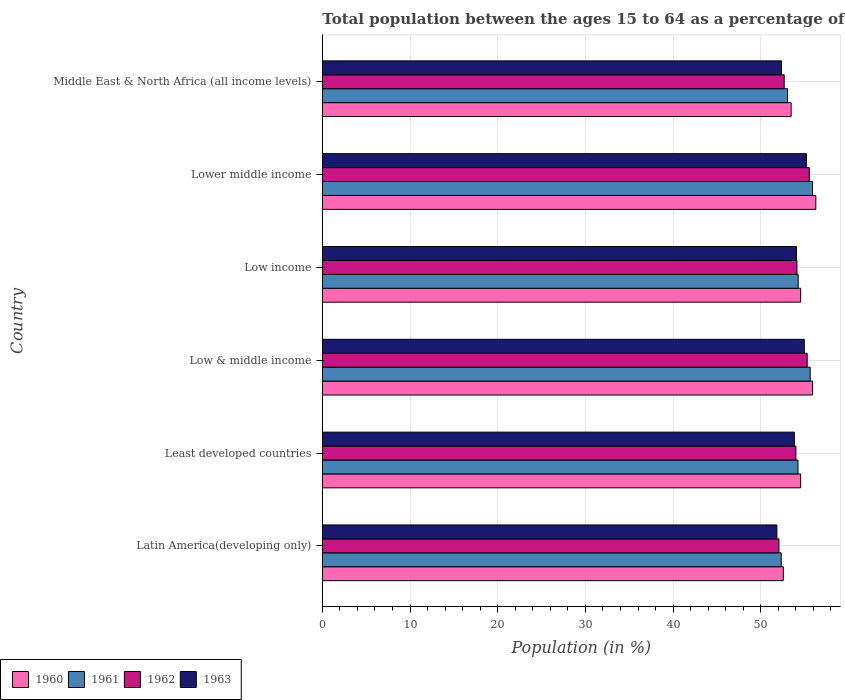How many bars are there on the 2nd tick from the top?
Keep it short and to the point. 4. What is the label of the 5th group of bars from the top?
Provide a short and direct response. Least developed countries. What is the percentage of the population ages 15 to 64 in 1963 in Least developed countries?
Offer a terse response. 53.82. Across all countries, what is the maximum percentage of the population ages 15 to 64 in 1961?
Your answer should be very brief. 55.89. Across all countries, what is the minimum percentage of the population ages 15 to 64 in 1960?
Offer a terse response. 52.56. In which country was the percentage of the population ages 15 to 64 in 1961 maximum?
Keep it short and to the point. Lower middle income. In which country was the percentage of the population ages 15 to 64 in 1961 minimum?
Your answer should be very brief. Latin America(developing only). What is the total percentage of the population ages 15 to 64 in 1963 in the graph?
Provide a succinct answer. 322.22. What is the difference between the percentage of the population ages 15 to 64 in 1962 in Latin America(developing only) and that in Least developed countries?
Ensure brevity in your answer.  -1.94. What is the difference between the percentage of the population ages 15 to 64 in 1962 in Latin America(developing only) and the percentage of the population ages 15 to 64 in 1961 in Lower middle income?
Your response must be concise. -3.83. What is the average percentage of the population ages 15 to 64 in 1960 per country?
Your answer should be very brief. 54.55. What is the difference between the percentage of the population ages 15 to 64 in 1962 and percentage of the population ages 15 to 64 in 1960 in Lower middle income?
Provide a short and direct response. -0.74. What is the ratio of the percentage of the population ages 15 to 64 in 1961 in Latin America(developing only) to that in Middle East & North Africa (all income levels)?
Give a very brief answer. 0.99. What is the difference between the highest and the second highest percentage of the population ages 15 to 64 in 1960?
Your answer should be compact. 0.37. What is the difference between the highest and the lowest percentage of the population ages 15 to 64 in 1961?
Offer a terse response. 3.57. In how many countries, is the percentage of the population ages 15 to 64 in 1962 greater than the average percentage of the population ages 15 to 64 in 1962 taken over all countries?
Provide a short and direct response. 4. Is the sum of the percentage of the population ages 15 to 64 in 1961 in Latin America(developing only) and Least developed countries greater than the maximum percentage of the population ages 15 to 64 in 1960 across all countries?
Provide a short and direct response. Yes. Are all the bars in the graph horizontal?
Provide a succinct answer. Yes. How many countries are there in the graph?
Offer a very short reply. 6. How many legend labels are there?
Provide a succinct answer. 4. How are the legend labels stacked?
Your answer should be very brief. Horizontal. What is the title of the graph?
Your response must be concise. Total population between the ages 15 to 64 as a percentage of the total population. Does "1983" appear as one of the legend labels in the graph?
Ensure brevity in your answer.  No. What is the Population (in %) of 1960 in Latin America(developing only)?
Offer a very short reply. 52.56. What is the Population (in %) of 1961 in Latin America(developing only)?
Ensure brevity in your answer.  52.32. What is the Population (in %) of 1962 in Latin America(developing only)?
Offer a terse response. 52.06. What is the Population (in %) of 1963 in Latin America(developing only)?
Give a very brief answer. 51.83. What is the Population (in %) in 1960 in Least developed countries?
Your answer should be compact. 54.54. What is the Population (in %) in 1961 in Least developed countries?
Offer a very short reply. 54.24. What is the Population (in %) of 1962 in Least developed countries?
Keep it short and to the point. 54. What is the Population (in %) of 1963 in Least developed countries?
Give a very brief answer. 53.82. What is the Population (in %) of 1960 in Low & middle income?
Offer a terse response. 55.9. What is the Population (in %) in 1961 in Low & middle income?
Your answer should be compact. 55.63. What is the Population (in %) in 1962 in Low & middle income?
Keep it short and to the point. 55.29. What is the Population (in %) of 1963 in Low & middle income?
Keep it short and to the point. 54.96. What is the Population (in %) in 1960 in Low income?
Make the answer very short. 54.54. What is the Population (in %) of 1961 in Low income?
Make the answer very short. 54.26. What is the Population (in %) in 1962 in Low income?
Give a very brief answer. 54.11. What is the Population (in %) in 1963 in Low income?
Make the answer very short. 54.06. What is the Population (in %) of 1960 in Lower middle income?
Make the answer very short. 56.27. What is the Population (in %) in 1961 in Lower middle income?
Ensure brevity in your answer.  55.89. What is the Population (in %) of 1962 in Lower middle income?
Ensure brevity in your answer.  55.53. What is the Population (in %) in 1963 in Lower middle income?
Give a very brief answer. 55.2. What is the Population (in %) in 1960 in Middle East & North Africa (all income levels)?
Provide a succinct answer. 53.46. What is the Population (in %) in 1961 in Middle East & North Africa (all income levels)?
Your response must be concise. 53.04. What is the Population (in %) in 1962 in Middle East & North Africa (all income levels)?
Make the answer very short. 52.67. What is the Population (in %) in 1963 in Middle East & North Africa (all income levels)?
Provide a short and direct response. 52.35. Across all countries, what is the maximum Population (in %) in 1960?
Your response must be concise. 56.27. Across all countries, what is the maximum Population (in %) of 1961?
Provide a succinct answer. 55.89. Across all countries, what is the maximum Population (in %) of 1962?
Your response must be concise. 55.53. Across all countries, what is the maximum Population (in %) in 1963?
Give a very brief answer. 55.2. Across all countries, what is the minimum Population (in %) of 1960?
Your answer should be compact. 52.56. Across all countries, what is the minimum Population (in %) of 1961?
Offer a very short reply. 52.32. Across all countries, what is the minimum Population (in %) of 1962?
Your answer should be very brief. 52.06. Across all countries, what is the minimum Population (in %) in 1963?
Ensure brevity in your answer.  51.83. What is the total Population (in %) in 1960 in the graph?
Offer a terse response. 327.28. What is the total Population (in %) of 1961 in the graph?
Keep it short and to the point. 325.38. What is the total Population (in %) of 1962 in the graph?
Give a very brief answer. 323.65. What is the total Population (in %) in 1963 in the graph?
Make the answer very short. 322.22. What is the difference between the Population (in %) in 1960 in Latin America(developing only) and that in Least developed countries?
Ensure brevity in your answer.  -1.98. What is the difference between the Population (in %) of 1961 in Latin America(developing only) and that in Least developed countries?
Provide a succinct answer. -1.91. What is the difference between the Population (in %) of 1962 in Latin America(developing only) and that in Least developed countries?
Ensure brevity in your answer.  -1.94. What is the difference between the Population (in %) of 1963 in Latin America(developing only) and that in Least developed countries?
Keep it short and to the point. -1.99. What is the difference between the Population (in %) in 1960 in Latin America(developing only) and that in Low & middle income?
Your response must be concise. -3.34. What is the difference between the Population (in %) in 1961 in Latin America(developing only) and that in Low & middle income?
Ensure brevity in your answer.  -3.31. What is the difference between the Population (in %) in 1962 in Latin America(developing only) and that in Low & middle income?
Your response must be concise. -3.22. What is the difference between the Population (in %) in 1963 in Latin America(developing only) and that in Low & middle income?
Your answer should be very brief. -3.13. What is the difference between the Population (in %) of 1960 in Latin America(developing only) and that in Low income?
Ensure brevity in your answer.  -1.98. What is the difference between the Population (in %) in 1961 in Latin America(developing only) and that in Low income?
Give a very brief answer. -1.94. What is the difference between the Population (in %) in 1962 in Latin America(developing only) and that in Low income?
Make the answer very short. -2.05. What is the difference between the Population (in %) in 1963 in Latin America(developing only) and that in Low income?
Your answer should be very brief. -2.22. What is the difference between the Population (in %) in 1960 in Latin America(developing only) and that in Lower middle income?
Make the answer very short. -3.71. What is the difference between the Population (in %) in 1961 in Latin America(developing only) and that in Lower middle income?
Provide a succinct answer. -3.57. What is the difference between the Population (in %) of 1962 in Latin America(developing only) and that in Lower middle income?
Offer a very short reply. -3.46. What is the difference between the Population (in %) of 1963 in Latin America(developing only) and that in Lower middle income?
Keep it short and to the point. -3.37. What is the difference between the Population (in %) of 1960 in Latin America(developing only) and that in Middle East & North Africa (all income levels)?
Provide a succinct answer. -0.89. What is the difference between the Population (in %) of 1961 in Latin America(developing only) and that in Middle East & North Africa (all income levels)?
Provide a short and direct response. -0.72. What is the difference between the Population (in %) in 1962 in Latin America(developing only) and that in Middle East & North Africa (all income levels)?
Your answer should be compact. -0.6. What is the difference between the Population (in %) in 1963 in Latin America(developing only) and that in Middle East & North Africa (all income levels)?
Provide a succinct answer. -0.52. What is the difference between the Population (in %) of 1960 in Least developed countries and that in Low & middle income?
Give a very brief answer. -1.36. What is the difference between the Population (in %) in 1961 in Least developed countries and that in Low & middle income?
Your answer should be very brief. -1.39. What is the difference between the Population (in %) in 1962 in Least developed countries and that in Low & middle income?
Keep it short and to the point. -1.29. What is the difference between the Population (in %) in 1963 in Least developed countries and that in Low & middle income?
Offer a terse response. -1.13. What is the difference between the Population (in %) in 1960 in Least developed countries and that in Low income?
Your answer should be compact. 0. What is the difference between the Population (in %) of 1961 in Least developed countries and that in Low income?
Make the answer very short. -0.02. What is the difference between the Population (in %) in 1962 in Least developed countries and that in Low income?
Make the answer very short. -0.12. What is the difference between the Population (in %) in 1963 in Least developed countries and that in Low income?
Provide a short and direct response. -0.23. What is the difference between the Population (in %) in 1960 in Least developed countries and that in Lower middle income?
Ensure brevity in your answer.  -1.73. What is the difference between the Population (in %) of 1961 in Least developed countries and that in Lower middle income?
Provide a short and direct response. -1.66. What is the difference between the Population (in %) of 1962 in Least developed countries and that in Lower middle income?
Give a very brief answer. -1.53. What is the difference between the Population (in %) in 1963 in Least developed countries and that in Lower middle income?
Offer a terse response. -1.38. What is the difference between the Population (in %) in 1960 in Least developed countries and that in Middle East & North Africa (all income levels)?
Provide a short and direct response. 1.09. What is the difference between the Population (in %) in 1961 in Least developed countries and that in Middle East & North Africa (all income levels)?
Your answer should be compact. 1.19. What is the difference between the Population (in %) in 1962 in Least developed countries and that in Middle East & North Africa (all income levels)?
Ensure brevity in your answer.  1.33. What is the difference between the Population (in %) of 1963 in Least developed countries and that in Middle East & North Africa (all income levels)?
Your answer should be compact. 1.47. What is the difference between the Population (in %) in 1960 in Low & middle income and that in Low income?
Offer a terse response. 1.36. What is the difference between the Population (in %) of 1961 in Low & middle income and that in Low income?
Your answer should be very brief. 1.37. What is the difference between the Population (in %) of 1962 in Low & middle income and that in Low income?
Provide a short and direct response. 1.17. What is the difference between the Population (in %) in 1963 in Low & middle income and that in Low income?
Provide a short and direct response. 0.9. What is the difference between the Population (in %) of 1960 in Low & middle income and that in Lower middle income?
Your response must be concise. -0.37. What is the difference between the Population (in %) of 1961 in Low & middle income and that in Lower middle income?
Offer a terse response. -0.26. What is the difference between the Population (in %) of 1962 in Low & middle income and that in Lower middle income?
Keep it short and to the point. -0.24. What is the difference between the Population (in %) of 1963 in Low & middle income and that in Lower middle income?
Provide a succinct answer. -0.24. What is the difference between the Population (in %) in 1960 in Low & middle income and that in Middle East & North Africa (all income levels)?
Your answer should be very brief. 2.45. What is the difference between the Population (in %) in 1961 in Low & middle income and that in Middle East & North Africa (all income levels)?
Your answer should be very brief. 2.59. What is the difference between the Population (in %) of 1962 in Low & middle income and that in Middle East & North Africa (all income levels)?
Provide a succinct answer. 2.62. What is the difference between the Population (in %) of 1963 in Low & middle income and that in Middle East & North Africa (all income levels)?
Your answer should be very brief. 2.6. What is the difference between the Population (in %) in 1960 in Low income and that in Lower middle income?
Give a very brief answer. -1.73. What is the difference between the Population (in %) in 1961 in Low income and that in Lower middle income?
Provide a short and direct response. -1.63. What is the difference between the Population (in %) of 1962 in Low income and that in Lower middle income?
Give a very brief answer. -1.41. What is the difference between the Population (in %) of 1963 in Low income and that in Lower middle income?
Ensure brevity in your answer.  -1.14. What is the difference between the Population (in %) in 1960 in Low income and that in Middle East & North Africa (all income levels)?
Provide a short and direct response. 1.08. What is the difference between the Population (in %) of 1961 in Low income and that in Middle East & North Africa (all income levels)?
Make the answer very short. 1.22. What is the difference between the Population (in %) of 1962 in Low income and that in Middle East & North Africa (all income levels)?
Your answer should be very brief. 1.45. What is the difference between the Population (in %) of 1963 in Low income and that in Middle East & North Africa (all income levels)?
Make the answer very short. 1.7. What is the difference between the Population (in %) in 1960 in Lower middle income and that in Middle East & North Africa (all income levels)?
Make the answer very short. 2.81. What is the difference between the Population (in %) in 1961 in Lower middle income and that in Middle East & North Africa (all income levels)?
Your response must be concise. 2.85. What is the difference between the Population (in %) in 1962 in Lower middle income and that in Middle East & North Africa (all income levels)?
Offer a very short reply. 2.86. What is the difference between the Population (in %) in 1963 in Lower middle income and that in Middle East & North Africa (all income levels)?
Your answer should be compact. 2.85. What is the difference between the Population (in %) of 1960 in Latin America(developing only) and the Population (in %) of 1961 in Least developed countries?
Your answer should be very brief. -1.67. What is the difference between the Population (in %) of 1960 in Latin America(developing only) and the Population (in %) of 1962 in Least developed countries?
Provide a short and direct response. -1.44. What is the difference between the Population (in %) in 1960 in Latin America(developing only) and the Population (in %) in 1963 in Least developed countries?
Keep it short and to the point. -1.26. What is the difference between the Population (in %) of 1961 in Latin America(developing only) and the Population (in %) of 1962 in Least developed countries?
Give a very brief answer. -1.68. What is the difference between the Population (in %) in 1961 in Latin America(developing only) and the Population (in %) in 1963 in Least developed countries?
Offer a terse response. -1.5. What is the difference between the Population (in %) in 1962 in Latin America(developing only) and the Population (in %) in 1963 in Least developed countries?
Your response must be concise. -1.76. What is the difference between the Population (in %) of 1960 in Latin America(developing only) and the Population (in %) of 1961 in Low & middle income?
Offer a terse response. -3.07. What is the difference between the Population (in %) of 1960 in Latin America(developing only) and the Population (in %) of 1962 in Low & middle income?
Offer a very short reply. -2.72. What is the difference between the Population (in %) of 1960 in Latin America(developing only) and the Population (in %) of 1963 in Low & middle income?
Provide a succinct answer. -2.39. What is the difference between the Population (in %) of 1961 in Latin America(developing only) and the Population (in %) of 1962 in Low & middle income?
Your answer should be very brief. -2.96. What is the difference between the Population (in %) of 1961 in Latin America(developing only) and the Population (in %) of 1963 in Low & middle income?
Offer a very short reply. -2.63. What is the difference between the Population (in %) in 1962 in Latin America(developing only) and the Population (in %) in 1963 in Low & middle income?
Ensure brevity in your answer.  -2.89. What is the difference between the Population (in %) in 1960 in Latin America(developing only) and the Population (in %) in 1961 in Low income?
Your response must be concise. -1.7. What is the difference between the Population (in %) in 1960 in Latin America(developing only) and the Population (in %) in 1962 in Low income?
Keep it short and to the point. -1.55. What is the difference between the Population (in %) in 1960 in Latin America(developing only) and the Population (in %) in 1963 in Low income?
Provide a short and direct response. -1.49. What is the difference between the Population (in %) of 1961 in Latin America(developing only) and the Population (in %) of 1962 in Low income?
Give a very brief answer. -1.79. What is the difference between the Population (in %) of 1961 in Latin America(developing only) and the Population (in %) of 1963 in Low income?
Make the answer very short. -1.73. What is the difference between the Population (in %) of 1962 in Latin America(developing only) and the Population (in %) of 1963 in Low income?
Your answer should be very brief. -1.99. What is the difference between the Population (in %) in 1960 in Latin America(developing only) and the Population (in %) in 1961 in Lower middle income?
Offer a terse response. -3.33. What is the difference between the Population (in %) in 1960 in Latin America(developing only) and the Population (in %) in 1962 in Lower middle income?
Provide a succinct answer. -2.96. What is the difference between the Population (in %) of 1960 in Latin America(developing only) and the Population (in %) of 1963 in Lower middle income?
Offer a terse response. -2.64. What is the difference between the Population (in %) in 1961 in Latin America(developing only) and the Population (in %) in 1962 in Lower middle income?
Provide a short and direct response. -3.2. What is the difference between the Population (in %) in 1961 in Latin America(developing only) and the Population (in %) in 1963 in Lower middle income?
Offer a very short reply. -2.88. What is the difference between the Population (in %) in 1962 in Latin America(developing only) and the Population (in %) in 1963 in Lower middle income?
Offer a terse response. -3.14. What is the difference between the Population (in %) of 1960 in Latin America(developing only) and the Population (in %) of 1961 in Middle East & North Africa (all income levels)?
Keep it short and to the point. -0.48. What is the difference between the Population (in %) in 1960 in Latin America(developing only) and the Population (in %) in 1962 in Middle East & North Africa (all income levels)?
Provide a succinct answer. -0.1. What is the difference between the Population (in %) in 1960 in Latin America(developing only) and the Population (in %) in 1963 in Middle East & North Africa (all income levels)?
Your response must be concise. 0.21. What is the difference between the Population (in %) of 1961 in Latin America(developing only) and the Population (in %) of 1962 in Middle East & North Africa (all income levels)?
Ensure brevity in your answer.  -0.34. What is the difference between the Population (in %) in 1961 in Latin America(developing only) and the Population (in %) in 1963 in Middle East & North Africa (all income levels)?
Your answer should be compact. -0.03. What is the difference between the Population (in %) of 1962 in Latin America(developing only) and the Population (in %) of 1963 in Middle East & North Africa (all income levels)?
Ensure brevity in your answer.  -0.29. What is the difference between the Population (in %) of 1960 in Least developed countries and the Population (in %) of 1961 in Low & middle income?
Make the answer very short. -1.09. What is the difference between the Population (in %) in 1960 in Least developed countries and the Population (in %) in 1962 in Low & middle income?
Offer a terse response. -0.74. What is the difference between the Population (in %) of 1960 in Least developed countries and the Population (in %) of 1963 in Low & middle income?
Offer a terse response. -0.42. What is the difference between the Population (in %) in 1961 in Least developed countries and the Population (in %) in 1962 in Low & middle income?
Ensure brevity in your answer.  -1.05. What is the difference between the Population (in %) of 1961 in Least developed countries and the Population (in %) of 1963 in Low & middle income?
Provide a short and direct response. -0.72. What is the difference between the Population (in %) of 1962 in Least developed countries and the Population (in %) of 1963 in Low & middle income?
Your answer should be compact. -0.96. What is the difference between the Population (in %) of 1960 in Least developed countries and the Population (in %) of 1961 in Low income?
Your answer should be compact. 0.28. What is the difference between the Population (in %) of 1960 in Least developed countries and the Population (in %) of 1962 in Low income?
Offer a very short reply. 0.43. What is the difference between the Population (in %) of 1960 in Least developed countries and the Population (in %) of 1963 in Low income?
Your answer should be very brief. 0.49. What is the difference between the Population (in %) of 1961 in Least developed countries and the Population (in %) of 1962 in Low income?
Ensure brevity in your answer.  0.12. What is the difference between the Population (in %) in 1961 in Least developed countries and the Population (in %) in 1963 in Low income?
Give a very brief answer. 0.18. What is the difference between the Population (in %) in 1962 in Least developed countries and the Population (in %) in 1963 in Low income?
Your answer should be very brief. -0.06. What is the difference between the Population (in %) in 1960 in Least developed countries and the Population (in %) in 1961 in Lower middle income?
Make the answer very short. -1.35. What is the difference between the Population (in %) in 1960 in Least developed countries and the Population (in %) in 1962 in Lower middle income?
Your answer should be very brief. -0.98. What is the difference between the Population (in %) in 1960 in Least developed countries and the Population (in %) in 1963 in Lower middle income?
Your answer should be compact. -0.66. What is the difference between the Population (in %) in 1961 in Least developed countries and the Population (in %) in 1962 in Lower middle income?
Make the answer very short. -1.29. What is the difference between the Population (in %) of 1961 in Least developed countries and the Population (in %) of 1963 in Lower middle income?
Ensure brevity in your answer.  -0.96. What is the difference between the Population (in %) of 1962 in Least developed countries and the Population (in %) of 1963 in Lower middle income?
Ensure brevity in your answer.  -1.2. What is the difference between the Population (in %) in 1960 in Least developed countries and the Population (in %) in 1961 in Middle East & North Africa (all income levels)?
Ensure brevity in your answer.  1.5. What is the difference between the Population (in %) in 1960 in Least developed countries and the Population (in %) in 1962 in Middle East & North Africa (all income levels)?
Give a very brief answer. 1.88. What is the difference between the Population (in %) of 1960 in Least developed countries and the Population (in %) of 1963 in Middle East & North Africa (all income levels)?
Provide a succinct answer. 2.19. What is the difference between the Population (in %) of 1961 in Least developed countries and the Population (in %) of 1962 in Middle East & North Africa (all income levels)?
Provide a short and direct response. 1.57. What is the difference between the Population (in %) in 1961 in Least developed countries and the Population (in %) in 1963 in Middle East & North Africa (all income levels)?
Ensure brevity in your answer.  1.88. What is the difference between the Population (in %) of 1962 in Least developed countries and the Population (in %) of 1963 in Middle East & North Africa (all income levels)?
Give a very brief answer. 1.65. What is the difference between the Population (in %) in 1960 in Low & middle income and the Population (in %) in 1961 in Low income?
Keep it short and to the point. 1.64. What is the difference between the Population (in %) of 1960 in Low & middle income and the Population (in %) of 1962 in Low income?
Make the answer very short. 1.79. What is the difference between the Population (in %) in 1960 in Low & middle income and the Population (in %) in 1963 in Low income?
Provide a short and direct response. 1.85. What is the difference between the Population (in %) in 1961 in Low & middle income and the Population (in %) in 1962 in Low income?
Offer a very short reply. 1.51. What is the difference between the Population (in %) in 1961 in Low & middle income and the Population (in %) in 1963 in Low income?
Provide a succinct answer. 1.57. What is the difference between the Population (in %) in 1962 in Low & middle income and the Population (in %) in 1963 in Low income?
Provide a short and direct response. 1.23. What is the difference between the Population (in %) in 1960 in Low & middle income and the Population (in %) in 1961 in Lower middle income?
Ensure brevity in your answer.  0.01. What is the difference between the Population (in %) in 1960 in Low & middle income and the Population (in %) in 1962 in Lower middle income?
Provide a succinct answer. 0.38. What is the difference between the Population (in %) of 1960 in Low & middle income and the Population (in %) of 1963 in Lower middle income?
Offer a very short reply. 0.7. What is the difference between the Population (in %) in 1961 in Low & middle income and the Population (in %) in 1962 in Lower middle income?
Provide a short and direct response. 0.1. What is the difference between the Population (in %) of 1961 in Low & middle income and the Population (in %) of 1963 in Lower middle income?
Keep it short and to the point. 0.43. What is the difference between the Population (in %) of 1962 in Low & middle income and the Population (in %) of 1963 in Lower middle income?
Make the answer very short. 0.09. What is the difference between the Population (in %) in 1960 in Low & middle income and the Population (in %) in 1961 in Middle East & North Africa (all income levels)?
Provide a succinct answer. 2.86. What is the difference between the Population (in %) of 1960 in Low & middle income and the Population (in %) of 1962 in Middle East & North Africa (all income levels)?
Keep it short and to the point. 3.24. What is the difference between the Population (in %) in 1960 in Low & middle income and the Population (in %) in 1963 in Middle East & North Africa (all income levels)?
Keep it short and to the point. 3.55. What is the difference between the Population (in %) in 1961 in Low & middle income and the Population (in %) in 1962 in Middle East & North Africa (all income levels)?
Offer a very short reply. 2.96. What is the difference between the Population (in %) of 1961 in Low & middle income and the Population (in %) of 1963 in Middle East & North Africa (all income levels)?
Give a very brief answer. 3.28. What is the difference between the Population (in %) in 1962 in Low & middle income and the Population (in %) in 1963 in Middle East & North Africa (all income levels)?
Your answer should be compact. 2.93. What is the difference between the Population (in %) in 1960 in Low income and the Population (in %) in 1961 in Lower middle income?
Provide a short and direct response. -1.35. What is the difference between the Population (in %) in 1960 in Low income and the Population (in %) in 1962 in Lower middle income?
Give a very brief answer. -0.98. What is the difference between the Population (in %) in 1960 in Low income and the Population (in %) in 1963 in Lower middle income?
Give a very brief answer. -0.66. What is the difference between the Population (in %) in 1961 in Low income and the Population (in %) in 1962 in Lower middle income?
Your answer should be very brief. -1.27. What is the difference between the Population (in %) in 1961 in Low income and the Population (in %) in 1963 in Lower middle income?
Your answer should be very brief. -0.94. What is the difference between the Population (in %) in 1962 in Low income and the Population (in %) in 1963 in Lower middle income?
Your answer should be very brief. -1.09. What is the difference between the Population (in %) of 1960 in Low income and the Population (in %) of 1961 in Middle East & North Africa (all income levels)?
Your answer should be very brief. 1.5. What is the difference between the Population (in %) of 1960 in Low income and the Population (in %) of 1962 in Middle East & North Africa (all income levels)?
Ensure brevity in your answer.  1.88. What is the difference between the Population (in %) in 1960 in Low income and the Population (in %) in 1963 in Middle East & North Africa (all income levels)?
Offer a very short reply. 2.19. What is the difference between the Population (in %) of 1961 in Low income and the Population (in %) of 1962 in Middle East & North Africa (all income levels)?
Provide a short and direct response. 1.59. What is the difference between the Population (in %) of 1961 in Low income and the Population (in %) of 1963 in Middle East & North Africa (all income levels)?
Make the answer very short. 1.91. What is the difference between the Population (in %) of 1962 in Low income and the Population (in %) of 1963 in Middle East & North Africa (all income levels)?
Keep it short and to the point. 1.76. What is the difference between the Population (in %) in 1960 in Lower middle income and the Population (in %) in 1961 in Middle East & North Africa (all income levels)?
Offer a terse response. 3.23. What is the difference between the Population (in %) in 1960 in Lower middle income and the Population (in %) in 1962 in Middle East & North Africa (all income levels)?
Your answer should be very brief. 3.6. What is the difference between the Population (in %) of 1960 in Lower middle income and the Population (in %) of 1963 in Middle East & North Africa (all income levels)?
Keep it short and to the point. 3.92. What is the difference between the Population (in %) of 1961 in Lower middle income and the Population (in %) of 1962 in Middle East & North Africa (all income levels)?
Keep it short and to the point. 3.23. What is the difference between the Population (in %) of 1961 in Lower middle income and the Population (in %) of 1963 in Middle East & North Africa (all income levels)?
Offer a terse response. 3.54. What is the difference between the Population (in %) in 1962 in Lower middle income and the Population (in %) in 1963 in Middle East & North Africa (all income levels)?
Keep it short and to the point. 3.17. What is the average Population (in %) of 1960 per country?
Keep it short and to the point. 54.55. What is the average Population (in %) in 1961 per country?
Provide a succinct answer. 54.23. What is the average Population (in %) in 1962 per country?
Offer a very short reply. 53.94. What is the average Population (in %) of 1963 per country?
Provide a succinct answer. 53.7. What is the difference between the Population (in %) of 1960 and Population (in %) of 1961 in Latin America(developing only)?
Make the answer very short. 0.24. What is the difference between the Population (in %) of 1960 and Population (in %) of 1962 in Latin America(developing only)?
Offer a very short reply. 0.5. What is the difference between the Population (in %) in 1960 and Population (in %) in 1963 in Latin America(developing only)?
Your answer should be compact. 0.73. What is the difference between the Population (in %) in 1961 and Population (in %) in 1962 in Latin America(developing only)?
Offer a terse response. 0.26. What is the difference between the Population (in %) of 1961 and Population (in %) of 1963 in Latin America(developing only)?
Ensure brevity in your answer.  0.49. What is the difference between the Population (in %) of 1962 and Population (in %) of 1963 in Latin America(developing only)?
Ensure brevity in your answer.  0.23. What is the difference between the Population (in %) in 1960 and Population (in %) in 1961 in Least developed countries?
Ensure brevity in your answer.  0.31. What is the difference between the Population (in %) in 1960 and Population (in %) in 1962 in Least developed countries?
Offer a very short reply. 0.54. What is the difference between the Population (in %) in 1960 and Population (in %) in 1963 in Least developed countries?
Ensure brevity in your answer.  0.72. What is the difference between the Population (in %) of 1961 and Population (in %) of 1962 in Least developed countries?
Offer a very short reply. 0.24. What is the difference between the Population (in %) in 1961 and Population (in %) in 1963 in Least developed countries?
Offer a terse response. 0.41. What is the difference between the Population (in %) in 1962 and Population (in %) in 1963 in Least developed countries?
Offer a terse response. 0.18. What is the difference between the Population (in %) of 1960 and Population (in %) of 1961 in Low & middle income?
Your answer should be very brief. 0.27. What is the difference between the Population (in %) of 1960 and Population (in %) of 1962 in Low & middle income?
Your answer should be compact. 0.62. What is the difference between the Population (in %) of 1960 and Population (in %) of 1963 in Low & middle income?
Provide a short and direct response. 0.95. What is the difference between the Population (in %) in 1961 and Population (in %) in 1962 in Low & middle income?
Your response must be concise. 0.34. What is the difference between the Population (in %) of 1961 and Population (in %) of 1963 in Low & middle income?
Offer a terse response. 0.67. What is the difference between the Population (in %) of 1962 and Population (in %) of 1963 in Low & middle income?
Give a very brief answer. 0.33. What is the difference between the Population (in %) of 1960 and Population (in %) of 1961 in Low income?
Provide a succinct answer. 0.28. What is the difference between the Population (in %) in 1960 and Population (in %) in 1962 in Low income?
Offer a very short reply. 0.43. What is the difference between the Population (in %) in 1960 and Population (in %) in 1963 in Low income?
Provide a succinct answer. 0.49. What is the difference between the Population (in %) in 1961 and Population (in %) in 1962 in Low income?
Give a very brief answer. 0.14. What is the difference between the Population (in %) of 1961 and Population (in %) of 1963 in Low income?
Your answer should be very brief. 0.2. What is the difference between the Population (in %) of 1962 and Population (in %) of 1963 in Low income?
Provide a short and direct response. 0.06. What is the difference between the Population (in %) in 1960 and Population (in %) in 1961 in Lower middle income?
Ensure brevity in your answer.  0.38. What is the difference between the Population (in %) in 1960 and Population (in %) in 1962 in Lower middle income?
Your answer should be compact. 0.74. What is the difference between the Population (in %) in 1960 and Population (in %) in 1963 in Lower middle income?
Give a very brief answer. 1.07. What is the difference between the Population (in %) in 1961 and Population (in %) in 1962 in Lower middle income?
Ensure brevity in your answer.  0.37. What is the difference between the Population (in %) of 1961 and Population (in %) of 1963 in Lower middle income?
Your response must be concise. 0.69. What is the difference between the Population (in %) in 1962 and Population (in %) in 1963 in Lower middle income?
Keep it short and to the point. 0.33. What is the difference between the Population (in %) in 1960 and Population (in %) in 1961 in Middle East & North Africa (all income levels)?
Provide a succinct answer. 0.42. What is the difference between the Population (in %) in 1960 and Population (in %) in 1962 in Middle East & North Africa (all income levels)?
Ensure brevity in your answer.  0.79. What is the difference between the Population (in %) of 1960 and Population (in %) of 1963 in Middle East & North Africa (all income levels)?
Your response must be concise. 1.1. What is the difference between the Population (in %) in 1961 and Population (in %) in 1962 in Middle East & North Africa (all income levels)?
Provide a succinct answer. 0.38. What is the difference between the Population (in %) of 1961 and Population (in %) of 1963 in Middle East & North Africa (all income levels)?
Provide a short and direct response. 0.69. What is the difference between the Population (in %) in 1962 and Population (in %) in 1963 in Middle East & North Africa (all income levels)?
Provide a short and direct response. 0.31. What is the ratio of the Population (in %) in 1960 in Latin America(developing only) to that in Least developed countries?
Offer a very short reply. 0.96. What is the ratio of the Population (in %) of 1961 in Latin America(developing only) to that in Least developed countries?
Offer a very short reply. 0.96. What is the ratio of the Population (in %) of 1962 in Latin America(developing only) to that in Least developed countries?
Ensure brevity in your answer.  0.96. What is the ratio of the Population (in %) of 1960 in Latin America(developing only) to that in Low & middle income?
Offer a terse response. 0.94. What is the ratio of the Population (in %) in 1961 in Latin America(developing only) to that in Low & middle income?
Provide a succinct answer. 0.94. What is the ratio of the Population (in %) of 1962 in Latin America(developing only) to that in Low & middle income?
Provide a succinct answer. 0.94. What is the ratio of the Population (in %) in 1963 in Latin America(developing only) to that in Low & middle income?
Give a very brief answer. 0.94. What is the ratio of the Population (in %) of 1960 in Latin America(developing only) to that in Low income?
Ensure brevity in your answer.  0.96. What is the ratio of the Population (in %) in 1962 in Latin America(developing only) to that in Low income?
Ensure brevity in your answer.  0.96. What is the ratio of the Population (in %) of 1963 in Latin America(developing only) to that in Low income?
Your answer should be very brief. 0.96. What is the ratio of the Population (in %) of 1960 in Latin America(developing only) to that in Lower middle income?
Keep it short and to the point. 0.93. What is the ratio of the Population (in %) in 1961 in Latin America(developing only) to that in Lower middle income?
Ensure brevity in your answer.  0.94. What is the ratio of the Population (in %) in 1962 in Latin America(developing only) to that in Lower middle income?
Keep it short and to the point. 0.94. What is the ratio of the Population (in %) of 1963 in Latin America(developing only) to that in Lower middle income?
Offer a very short reply. 0.94. What is the ratio of the Population (in %) of 1960 in Latin America(developing only) to that in Middle East & North Africa (all income levels)?
Provide a succinct answer. 0.98. What is the ratio of the Population (in %) in 1961 in Latin America(developing only) to that in Middle East & North Africa (all income levels)?
Offer a very short reply. 0.99. What is the ratio of the Population (in %) of 1960 in Least developed countries to that in Low & middle income?
Offer a very short reply. 0.98. What is the ratio of the Population (in %) in 1961 in Least developed countries to that in Low & middle income?
Your answer should be very brief. 0.97. What is the ratio of the Population (in %) in 1962 in Least developed countries to that in Low & middle income?
Provide a short and direct response. 0.98. What is the ratio of the Population (in %) of 1963 in Least developed countries to that in Low & middle income?
Make the answer very short. 0.98. What is the ratio of the Population (in %) of 1963 in Least developed countries to that in Low income?
Give a very brief answer. 1. What is the ratio of the Population (in %) in 1960 in Least developed countries to that in Lower middle income?
Keep it short and to the point. 0.97. What is the ratio of the Population (in %) of 1961 in Least developed countries to that in Lower middle income?
Give a very brief answer. 0.97. What is the ratio of the Population (in %) in 1962 in Least developed countries to that in Lower middle income?
Ensure brevity in your answer.  0.97. What is the ratio of the Population (in %) of 1963 in Least developed countries to that in Lower middle income?
Give a very brief answer. 0.97. What is the ratio of the Population (in %) in 1960 in Least developed countries to that in Middle East & North Africa (all income levels)?
Your response must be concise. 1.02. What is the ratio of the Population (in %) of 1961 in Least developed countries to that in Middle East & North Africa (all income levels)?
Give a very brief answer. 1.02. What is the ratio of the Population (in %) in 1962 in Least developed countries to that in Middle East & North Africa (all income levels)?
Keep it short and to the point. 1.03. What is the ratio of the Population (in %) in 1963 in Least developed countries to that in Middle East & North Africa (all income levels)?
Provide a short and direct response. 1.03. What is the ratio of the Population (in %) in 1961 in Low & middle income to that in Low income?
Your answer should be compact. 1.03. What is the ratio of the Population (in %) of 1962 in Low & middle income to that in Low income?
Provide a short and direct response. 1.02. What is the ratio of the Population (in %) of 1963 in Low & middle income to that in Low income?
Your answer should be very brief. 1.02. What is the ratio of the Population (in %) in 1961 in Low & middle income to that in Lower middle income?
Your response must be concise. 1. What is the ratio of the Population (in %) in 1960 in Low & middle income to that in Middle East & North Africa (all income levels)?
Give a very brief answer. 1.05. What is the ratio of the Population (in %) of 1961 in Low & middle income to that in Middle East & North Africa (all income levels)?
Your answer should be very brief. 1.05. What is the ratio of the Population (in %) of 1962 in Low & middle income to that in Middle East & North Africa (all income levels)?
Your response must be concise. 1.05. What is the ratio of the Population (in %) of 1963 in Low & middle income to that in Middle East & North Africa (all income levels)?
Ensure brevity in your answer.  1.05. What is the ratio of the Population (in %) of 1960 in Low income to that in Lower middle income?
Offer a terse response. 0.97. What is the ratio of the Population (in %) of 1961 in Low income to that in Lower middle income?
Make the answer very short. 0.97. What is the ratio of the Population (in %) in 1962 in Low income to that in Lower middle income?
Your response must be concise. 0.97. What is the ratio of the Population (in %) of 1963 in Low income to that in Lower middle income?
Keep it short and to the point. 0.98. What is the ratio of the Population (in %) in 1960 in Low income to that in Middle East & North Africa (all income levels)?
Give a very brief answer. 1.02. What is the ratio of the Population (in %) in 1961 in Low income to that in Middle East & North Africa (all income levels)?
Give a very brief answer. 1.02. What is the ratio of the Population (in %) of 1962 in Low income to that in Middle East & North Africa (all income levels)?
Give a very brief answer. 1.03. What is the ratio of the Population (in %) in 1963 in Low income to that in Middle East & North Africa (all income levels)?
Keep it short and to the point. 1.03. What is the ratio of the Population (in %) of 1960 in Lower middle income to that in Middle East & North Africa (all income levels)?
Provide a succinct answer. 1.05. What is the ratio of the Population (in %) in 1961 in Lower middle income to that in Middle East & North Africa (all income levels)?
Your answer should be very brief. 1.05. What is the ratio of the Population (in %) of 1962 in Lower middle income to that in Middle East & North Africa (all income levels)?
Keep it short and to the point. 1.05. What is the ratio of the Population (in %) in 1963 in Lower middle income to that in Middle East & North Africa (all income levels)?
Give a very brief answer. 1.05. What is the difference between the highest and the second highest Population (in %) in 1960?
Keep it short and to the point. 0.37. What is the difference between the highest and the second highest Population (in %) of 1961?
Offer a very short reply. 0.26. What is the difference between the highest and the second highest Population (in %) of 1962?
Provide a short and direct response. 0.24. What is the difference between the highest and the second highest Population (in %) in 1963?
Provide a short and direct response. 0.24. What is the difference between the highest and the lowest Population (in %) of 1960?
Provide a succinct answer. 3.71. What is the difference between the highest and the lowest Population (in %) in 1961?
Give a very brief answer. 3.57. What is the difference between the highest and the lowest Population (in %) of 1962?
Your answer should be very brief. 3.46. What is the difference between the highest and the lowest Population (in %) of 1963?
Ensure brevity in your answer.  3.37. 